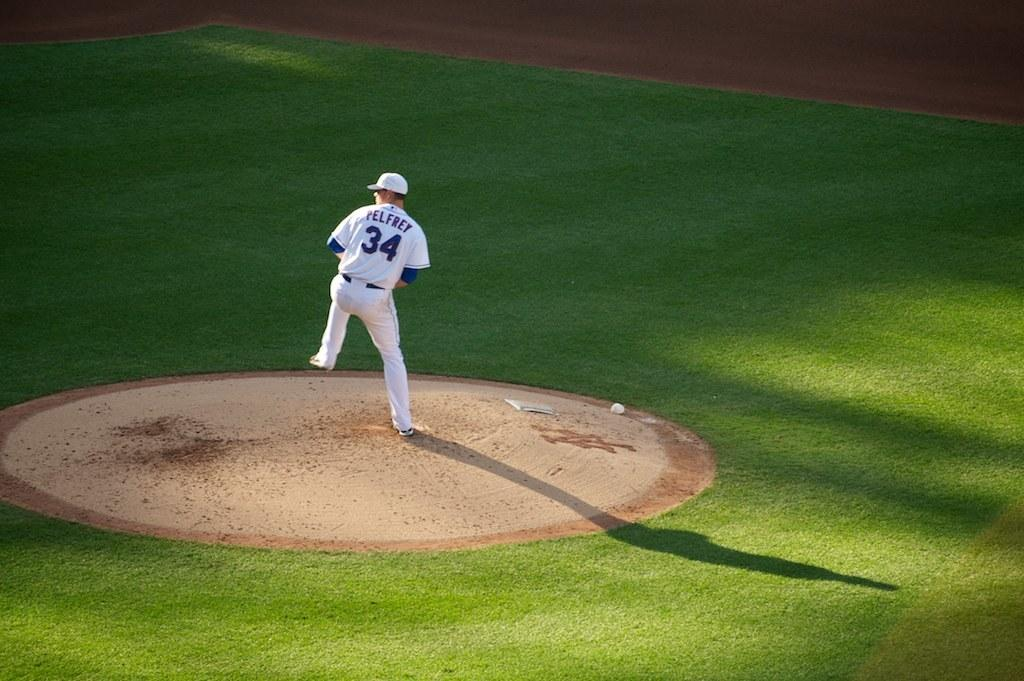<image>
Write a terse but informative summary of the picture. Baseball player Pelfrey gets ready to throw the ball. 